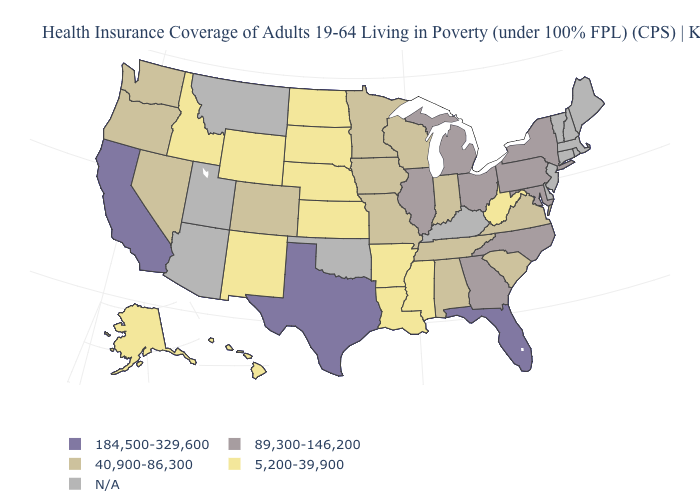Name the states that have a value in the range 40,900-86,300?
Quick response, please. Alabama, Colorado, Indiana, Iowa, Minnesota, Missouri, Nevada, Oregon, South Carolina, Tennessee, Virginia, Washington, Wisconsin. Name the states that have a value in the range 40,900-86,300?
Keep it brief. Alabama, Colorado, Indiana, Iowa, Minnesota, Missouri, Nevada, Oregon, South Carolina, Tennessee, Virginia, Washington, Wisconsin. Name the states that have a value in the range 40,900-86,300?
Answer briefly. Alabama, Colorado, Indiana, Iowa, Minnesota, Missouri, Nevada, Oregon, South Carolina, Tennessee, Virginia, Washington, Wisconsin. Which states have the highest value in the USA?
Concise answer only. California, Florida, Texas. Which states have the highest value in the USA?
Concise answer only. California, Florida, Texas. What is the highest value in the South ?
Give a very brief answer. 184,500-329,600. What is the value of New York?
Answer briefly. 89,300-146,200. What is the value of Texas?
Give a very brief answer. 184,500-329,600. Name the states that have a value in the range 184,500-329,600?
Be succinct. California, Florida, Texas. What is the value of New Mexico?
Quick response, please. 5,200-39,900. What is the value of Mississippi?
Be succinct. 5,200-39,900. Name the states that have a value in the range 40,900-86,300?
Quick response, please. Alabama, Colorado, Indiana, Iowa, Minnesota, Missouri, Nevada, Oregon, South Carolina, Tennessee, Virginia, Washington, Wisconsin. Does the first symbol in the legend represent the smallest category?
Write a very short answer. No. 